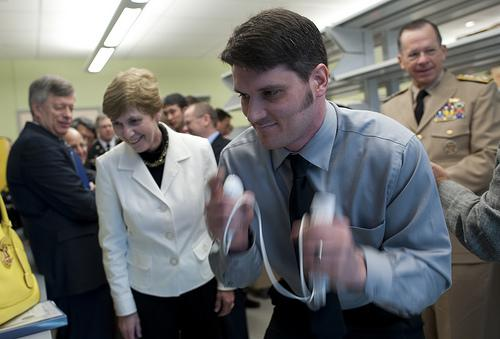Question: how is the room lit?
Choices:
A. Overhead lights are on.
B. A candle.
C. Glare from the television set.
D. Strobe light.
Answer with the letter. Answer: A Question: who is wearing a white jacket?
Choices:
A. A boy.
B. The doctor.
C. The lab assistant.
D. A woman.
Answer with the letter. Answer: D Question: who is wearing a uniform?
Choices:
A. The mailman.
B. The delivery truck driver.
C. A man.
D. The workers at a fast food restaurant.
Answer with the letter. Answer: C Question: what color shirt is the man in the foreground wearing?
Choices:
A. Blue.
B. Red.
C. Yellow.
D. Green.
Answer with the letter. Answer: A Question: how many buttons are on the front of the white jacket?
Choices:
A. Zero.
B. Five.
C. Too many to count.
D. Three.
Answer with the letter. Answer: D Question: why do the hands of the man in the foreground look blurry?
Choices:
A. The person taking the picture was moving.
B. Camera flaw.
C. He is moving.
D. Error during developing the film.
Answer with the letter. Answer: C 